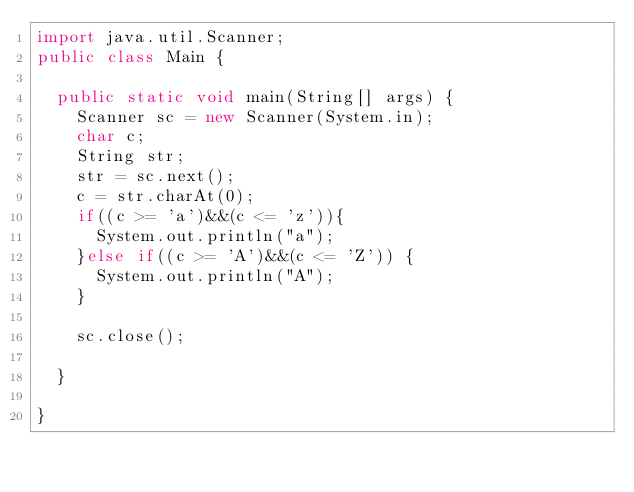<code> <loc_0><loc_0><loc_500><loc_500><_Java_>import java.util.Scanner;
public class Main {

	public static void main(String[] args) {
		Scanner sc = new Scanner(System.in);
		char c;
		String str;
		str = sc.next();
		c = str.charAt(0);
		if((c >= 'a')&&(c <= 'z')){
			System.out.println("a");
		}else if((c >= 'A')&&(c <= 'Z')) {
			System.out.println("A");
		}
		
		sc.close();

	}

}</code> 